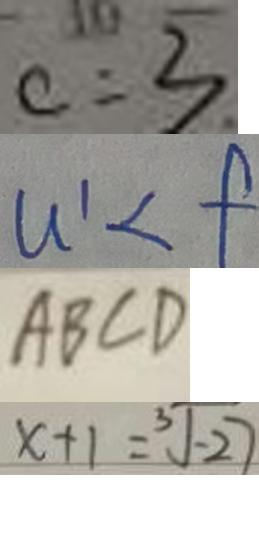Convert formula to latex. <formula><loc_0><loc_0><loc_500><loc_500>c = 3 
 u ^ { \prime } < f 
 A B C D 
 x + 1 = \sqrt [ 3 ] { - 2 7 }</formula> 